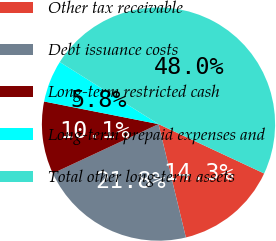<chart> <loc_0><loc_0><loc_500><loc_500><pie_chart><fcel>Other tax receivable<fcel>Debt issuance costs<fcel>Long-term restricted cash<fcel>Long-term prepaid expenses and<fcel>Total other long-term assets<nl><fcel>14.27%<fcel>21.83%<fcel>10.05%<fcel>5.83%<fcel>48.02%<nl></chart> 